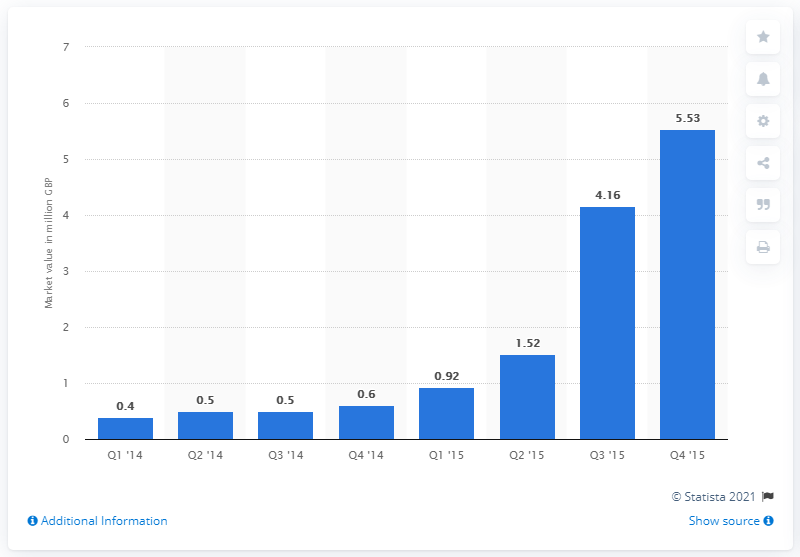Specify some key components in this picture. The debt-based crowdfunding market had a value of approximately $5.53 billion in the fourth quarter of 2015. The value of the debt-based crowdfunding market in the first quarter of 2014 was approximately $0.4 billion. 